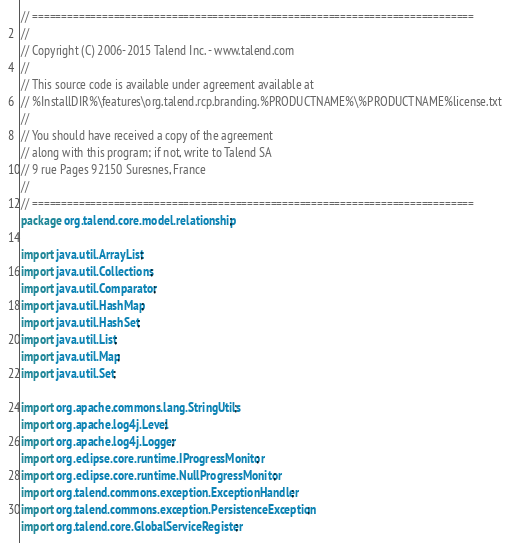<code> <loc_0><loc_0><loc_500><loc_500><_Java_>// ============================================================================
//
// Copyright (C) 2006-2015 Talend Inc. - www.talend.com
//
// This source code is available under agreement available at
// %InstallDIR%\features\org.talend.rcp.branding.%PRODUCTNAME%\%PRODUCTNAME%license.txt
//
// You should have received a copy of the agreement
// along with this program; if not, write to Talend SA
// 9 rue Pages 92150 Suresnes, France
//
// ============================================================================
package org.talend.core.model.relationship;

import java.util.ArrayList;
import java.util.Collections;
import java.util.Comparator;
import java.util.HashMap;
import java.util.HashSet;
import java.util.List;
import java.util.Map;
import java.util.Set;

import org.apache.commons.lang.StringUtils;
import org.apache.log4j.Level;
import org.apache.log4j.Logger;
import org.eclipse.core.runtime.IProgressMonitor;
import org.eclipse.core.runtime.NullProgressMonitor;
import org.talend.commons.exception.ExceptionHandler;
import org.talend.commons.exception.PersistenceException;
import org.talend.core.GlobalServiceRegister;</code> 